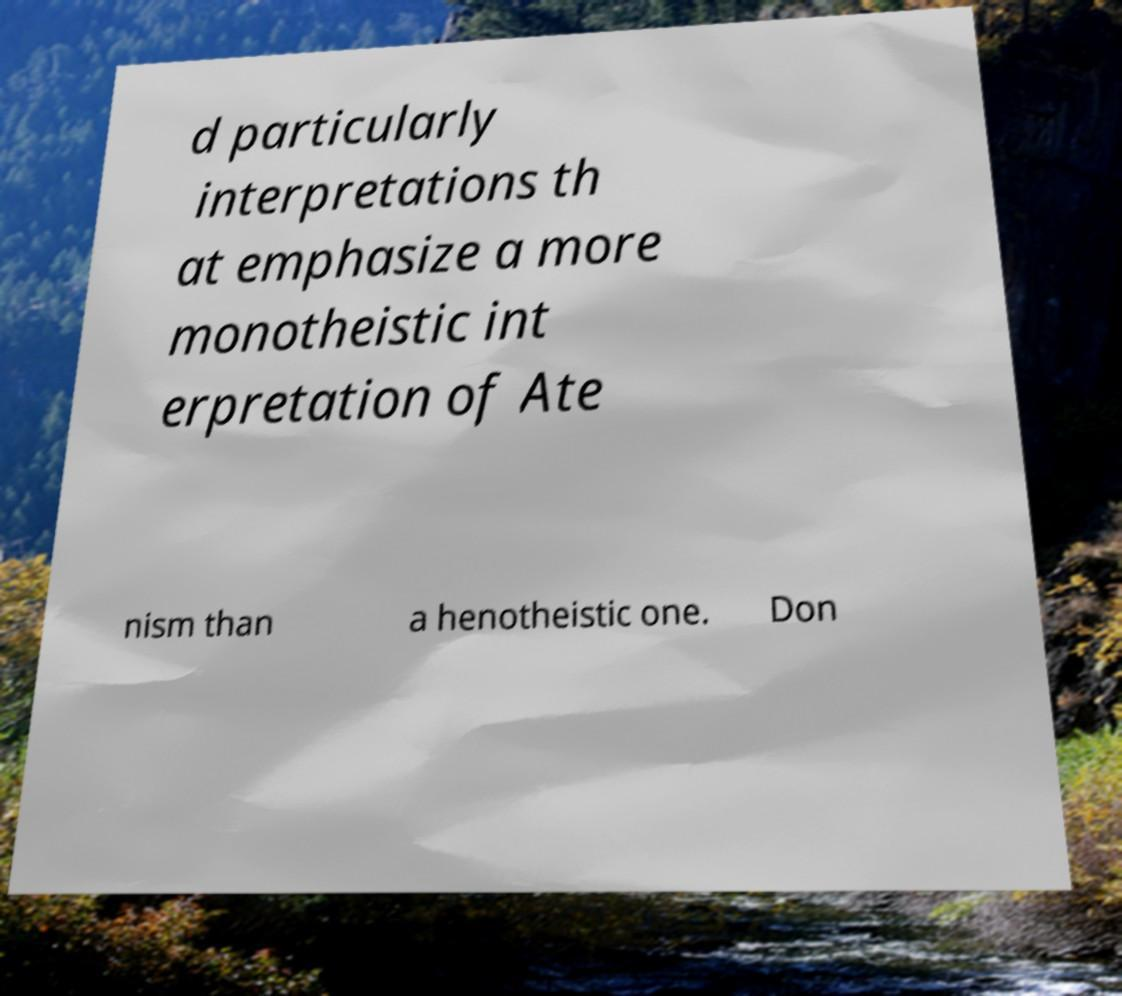What messages or text are displayed in this image? I need them in a readable, typed format. d particularly interpretations th at emphasize a more monotheistic int erpretation of Ate nism than a henotheistic one. Don 